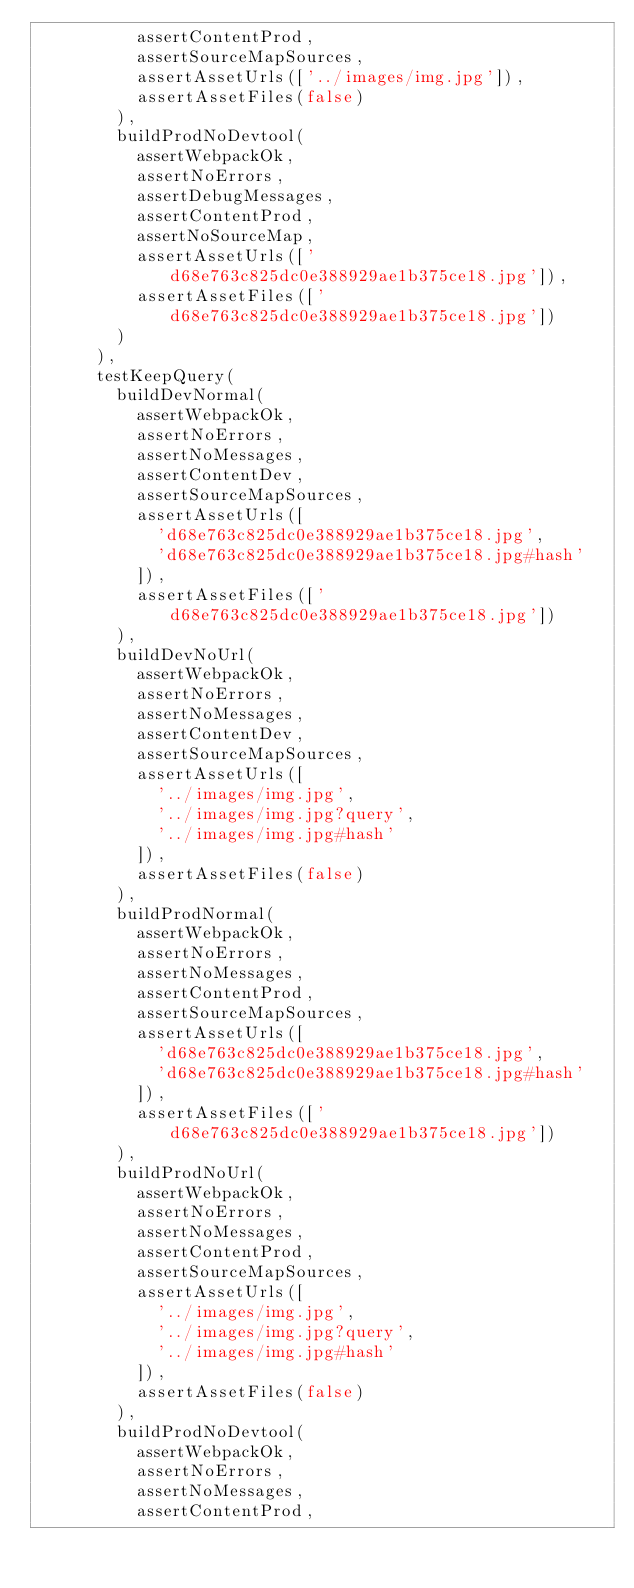<code> <loc_0><loc_0><loc_500><loc_500><_JavaScript_>          assertContentProd,
          assertSourceMapSources,
          assertAssetUrls(['../images/img.jpg']),
          assertAssetFiles(false)
        ),
        buildProdNoDevtool(
          assertWebpackOk,
          assertNoErrors,
          assertDebugMessages,
          assertContentProd,
          assertNoSourceMap,
          assertAssetUrls(['d68e763c825dc0e388929ae1b375ce18.jpg']),
          assertAssetFiles(['d68e763c825dc0e388929ae1b375ce18.jpg'])
        )
      ),
      testKeepQuery(
        buildDevNormal(
          assertWebpackOk,
          assertNoErrors,
          assertNoMessages,
          assertContentDev,
          assertSourceMapSources,
          assertAssetUrls([
            'd68e763c825dc0e388929ae1b375ce18.jpg',
            'd68e763c825dc0e388929ae1b375ce18.jpg#hash'
          ]),
          assertAssetFiles(['d68e763c825dc0e388929ae1b375ce18.jpg'])
        ),
        buildDevNoUrl(
          assertWebpackOk,
          assertNoErrors,
          assertNoMessages,
          assertContentDev,
          assertSourceMapSources,
          assertAssetUrls([
            '../images/img.jpg',
            '../images/img.jpg?query',
            '../images/img.jpg#hash'
          ]),
          assertAssetFiles(false)
        ),
        buildProdNormal(
          assertWebpackOk,
          assertNoErrors,
          assertNoMessages,
          assertContentProd,
          assertSourceMapSources,
          assertAssetUrls([
            'd68e763c825dc0e388929ae1b375ce18.jpg',
            'd68e763c825dc0e388929ae1b375ce18.jpg#hash'
          ]),
          assertAssetFiles(['d68e763c825dc0e388929ae1b375ce18.jpg'])
        ),
        buildProdNoUrl(
          assertWebpackOk,
          assertNoErrors,
          assertNoMessages,
          assertContentProd,
          assertSourceMapSources,
          assertAssetUrls([
            '../images/img.jpg',
            '../images/img.jpg?query',
            '../images/img.jpg#hash'
          ]),
          assertAssetFiles(false)
        ),
        buildProdNoDevtool(
          assertWebpackOk,
          assertNoErrors,
          assertNoMessages,
          assertContentProd,</code> 